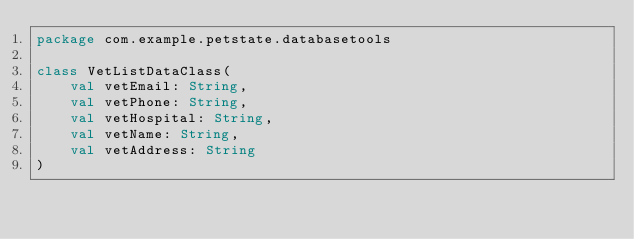Convert code to text. <code><loc_0><loc_0><loc_500><loc_500><_Kotlin_>package com.example.petstate.databasetools

class VetListDataClass(
    val vetEmail: String,
    val vetPhone: String,
    val vetHospital: String,
    val vetName: String,
    val vetAddress: String
)</code> 